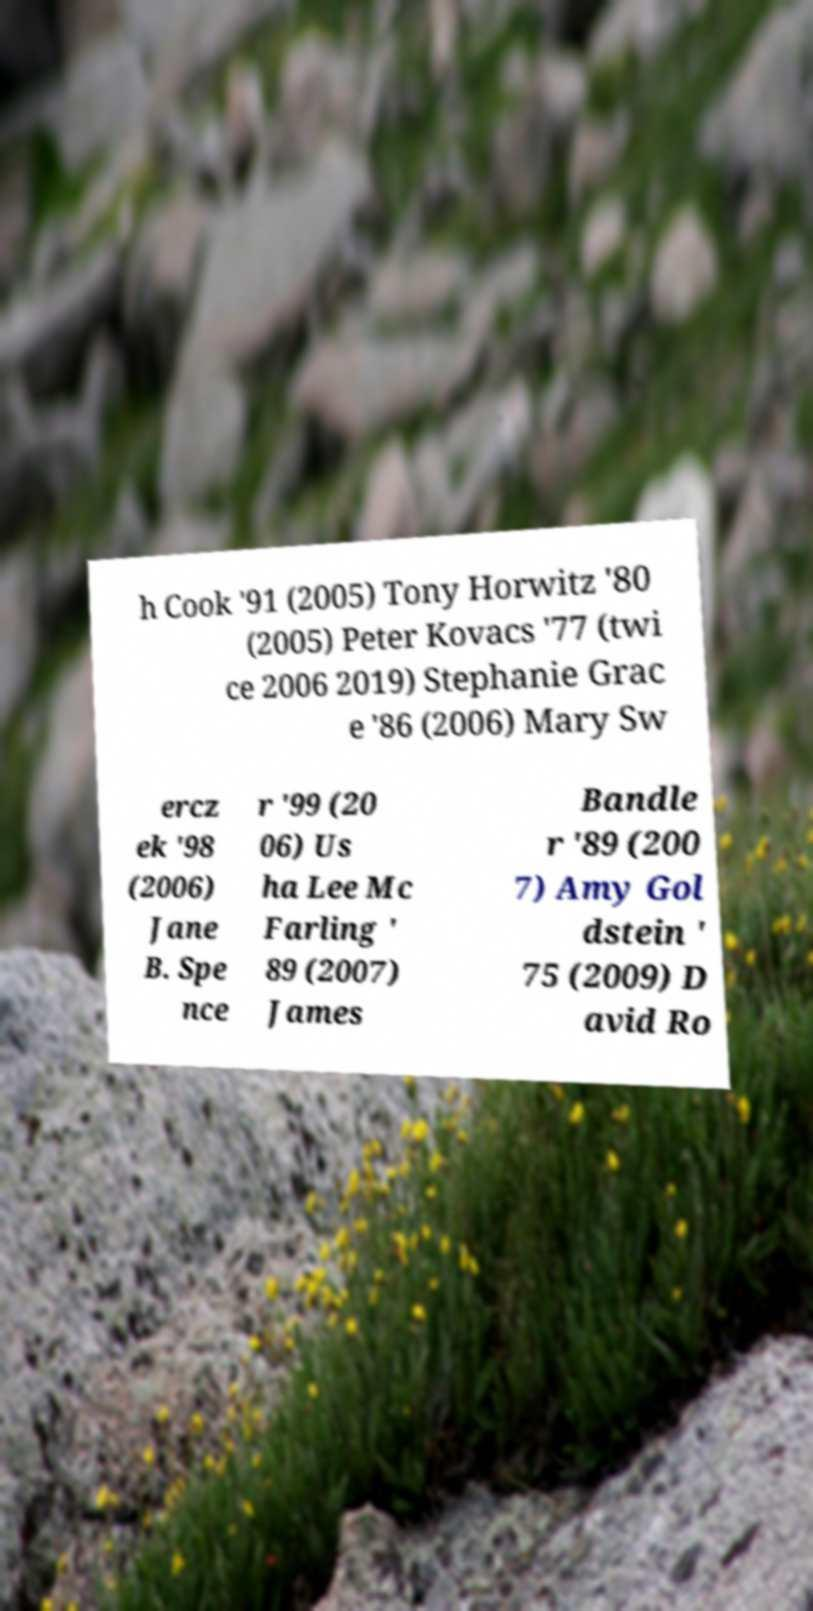Can you accurately transcribe the text from the provided image for me? h Cook '91 (2005) Tony Horwitz '80 (2005) Peter Kovacs '77 (twi ce 2006 2019) Stephanie Grac e '86 (2006) Mary Sw ercz ek '98 (2006) Jane B. Spe nce r '99 (20 06) Us ha Lee Mc Farling ' 89 (2007) James Bandle r '89 (200 7) Amy Gol dstein ' 75 (2009) D avid Ro 